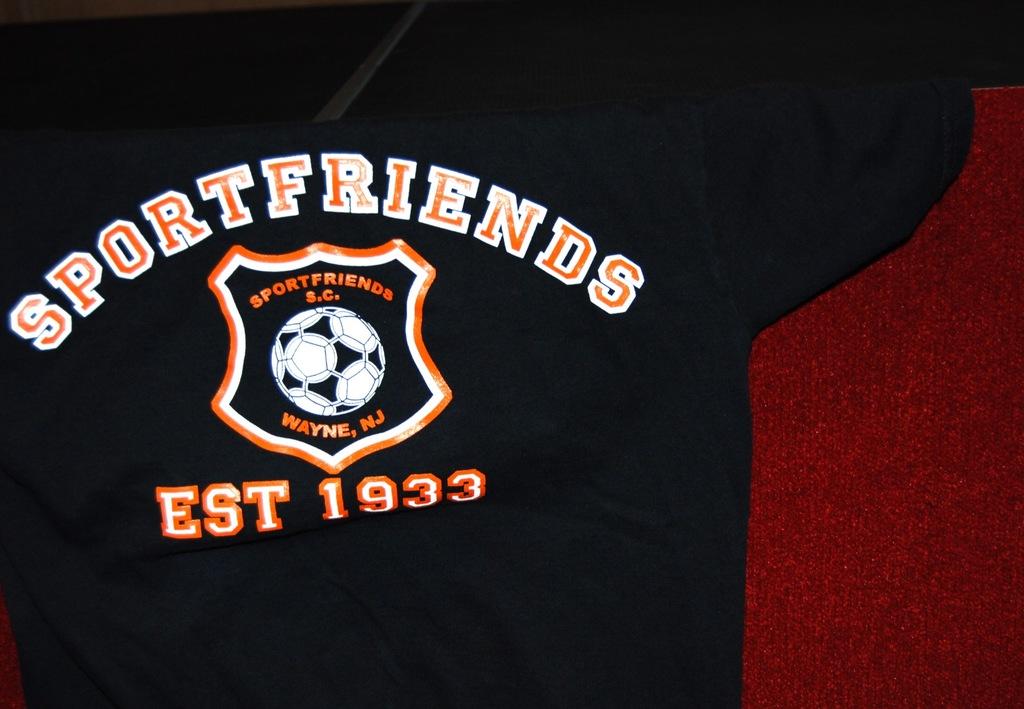What kind of friends does the shirt say?
Offer a terse response. Sport. What are the words inside the crest?
Offer a terse response. Sportfriends s.c. wayne, nj. 